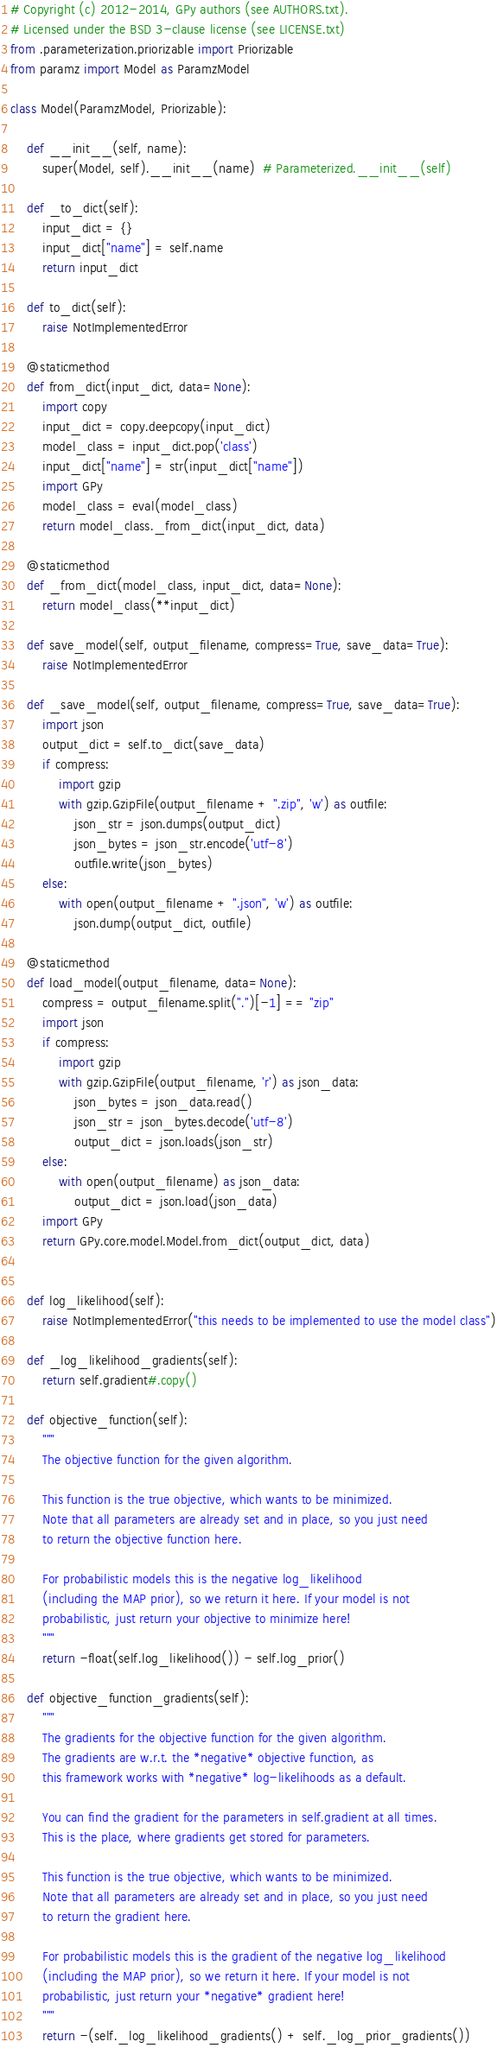<code> <loc_0><loc_0><loc_500><loc_500><_Python_># Copyright (c) 2012-2014, GPy authors (see AUTHORS.txt).
# Licensed under the BSD 3-clause license (see LICENSE.txt)
from .parameterization.priorizable import Priorizable
from paramz import Model as ParamzModel

class Model(ParamzModel, Priorizable):

    def __init__(self, name):
        super(Model, self).__init__(name)  # Parameterized.__init__(self)

    def _to_dict(self):
        input_dict = {}
        input_dict["name"] = self.name
        return input_dict

    def to_dict(self):
        raise NotImplementedError

    @staticmethod
    def from_dict(input_dict, data=None):
        import copy
        input_dict = copy.deepcopy(input_dict)
        model_class = input_dict.pop('class')
        input_dict["name"] = str(input_dict["name"])
        import GPy
        model_class = eval(model_class)
        return model_class._from_dict(input_dict, data)

    @staticmethod
    def _from_dict(model_class, input_dict, data=None):
        return model_class(**input_dict)

    def save_model(self, output_filename, compress=True, save_data=True):
        raise NotImplementedError

    def _save_model(self, output_filename, compress=True, save_data=True):
        import json
        output_dict = self.to_dict(save_data)
        if compress:
            import gzip
            with gzip.GzipFile(output_filename + ".zip", 'w') as outfile:
                json_str = json.dumps(output_dict)
                json_bytes = json_str.encode('utf-8')
                outfile.write(json_bytes)
        else:
            with open(output_filename + ".json", 'w') as outfile:
                json.dump(output_dict, outfile)

    @staticmethod
    def load_model(output_filename, data=None):
        compress = output_filename.split(".")[-1] == "zip"
        import json
        if compress:
            import gzip
            with gzip.GzipFile(output_filename, 'r') as json_data:
                json_bytes = json_data.read()
                json_str = json_bytes.decode('utf-8')
                output_dict = json.loads(json_str)
        else:
            with open(output_filename) as json_data:
                output_dict = json.load(json_data)
        import GPy
        return GPy.core.model.Model.from_dict(output_dict, data)


    def log_likelihood(self):
        raise NotImplementedError("this needs to be implemented to use the model class")

    def _log_likelihood_gradients(self):
        return self.gradient#.copy()

    def objective_function(self):
        """
        The objective function for the given algorithm.

        This function is the true objective, which wants to be minimized.
        Note that all parameters are already set and in place, so you just need
        to return the objective function here.

        For probabilistic models this is the negative log_likelihood
        (including the MAP prior), so we return it here. If your model is not
        probabilistic, just return your objective to minimize here!
        """
        return -float(self.log_likelihood()) - self.log_prior()

    def objective_function_gradients(self):
        """
        The gradients for the objective function for the given algorithm.
        The gradients are w.r.t. the *negative* objective function, as
        this framework works with *negative* log-likelihoods as a default.

        You can find the gradient for the parameters in self.gradient at all times.
        This is the place, where gradients get stored for parameters.

        This function is the true objective, which wants to be minimized.
        Note that all parameters are already set and in place, so you just need
        to return the gradient here.

        For probabilistic models this is the gradient of the negative log_likelihood
        (including the MAP prior), so we return it here. If your model is not
        probabilistic, just return your *negative* gradient here!
        """
        return -(self._log_likelihood_gradients() + self._log_prior_gradients())
</code> 